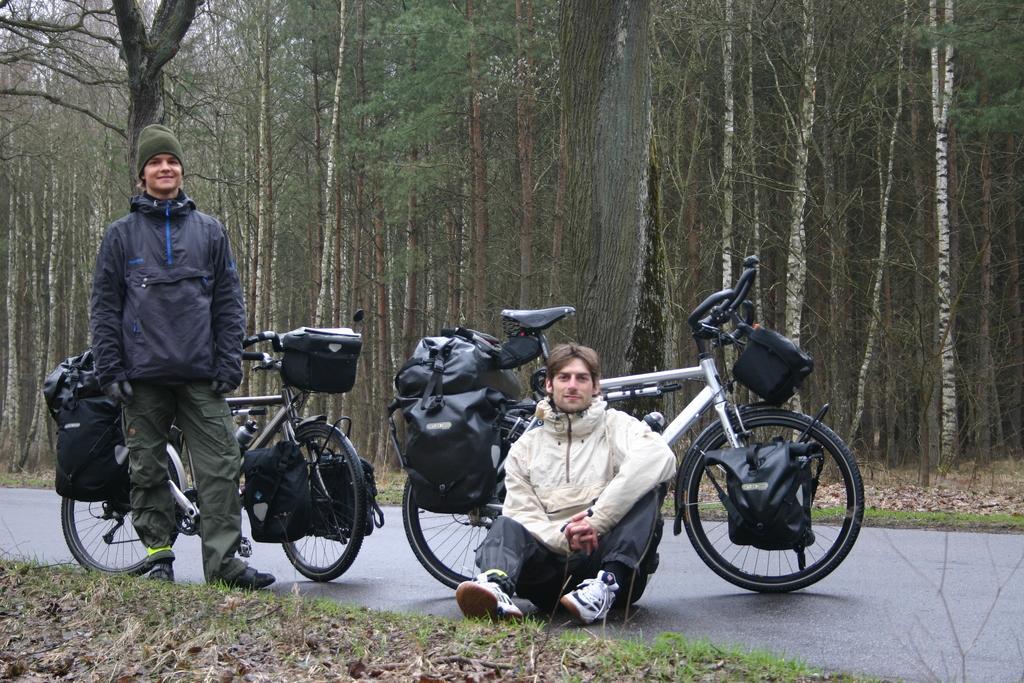Describe this image in one or two sentences. In this image there are two bicycles are packed with luggage on the road, in front of them there are two people, one is standing and the other is sitting. In the background there are trees. 